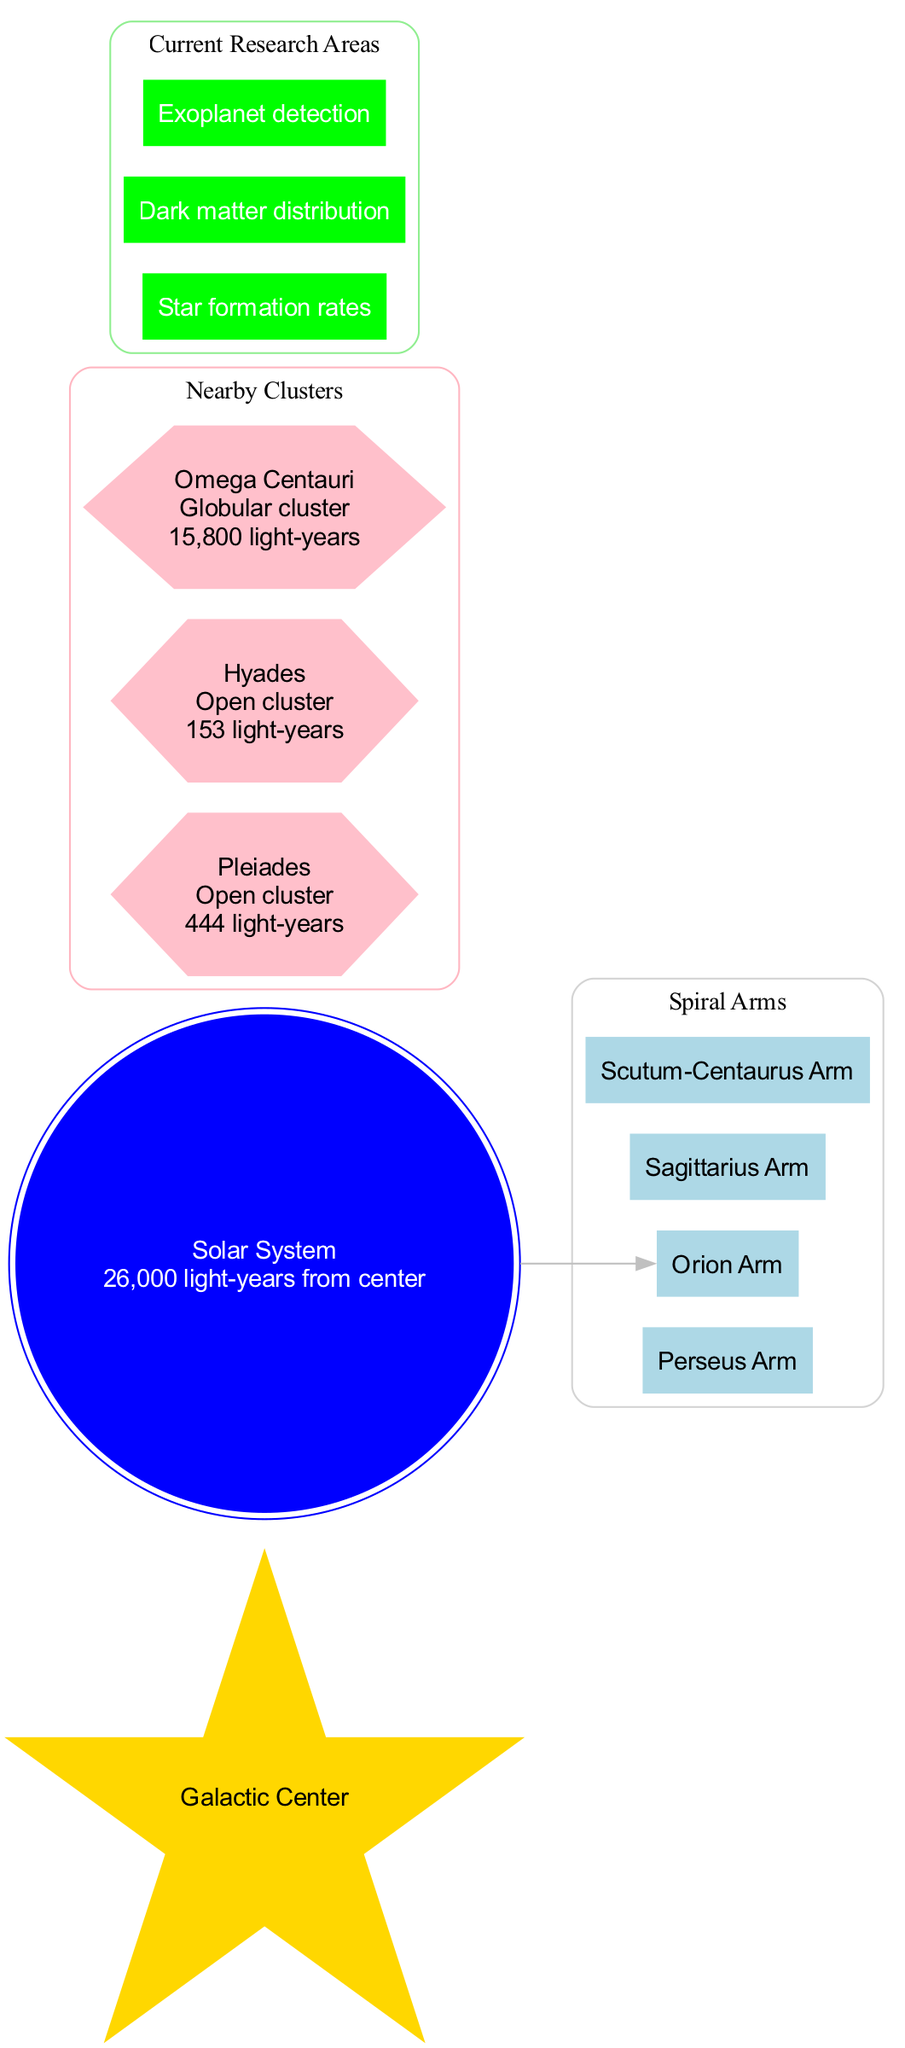What is the distance from the Solar System to the Galactic Center? The diagram indicates that the Solar System is 26,000 light-years away from the Galactic Center, which is explicitly noted next to the Solar System node.
Answer: 26,000 light-years How many spiral arms are shown in the diagram? The diagram lists four distinct spiral arms: Perseus Arm, Orion Arm, Sagittarius Arm, and Scutum-Centaurus Arm, which can be counted directly from the diagram's subgraph for spiral arms.
Answer: 4 Which arm is the Solar System located in? The diagram shows that the Solar System is located in the Orion Arm, indicated clearly by the edge connecting the Solar System node to the arm node.
Answer: Orion Arm What type of cluster is Pleiades? The Pleiades cluster is described as an Open cluster in the diagram, which is specified in its node details.
Answer: Open cluster What is the distance to Omega Centauri? According to the diagram, Omega Centauri is located 15,800 light-years away, as shown in the cluster's information on the diagram.
Answer: 15,800 light-years How many areas of current research are listed in the diagram? The diagram highlights three areas of current research: Star formation rates, Dark matter distribution, and Exoplanet detection, which can be counted directly from the information presented in the subgraph for research areas.
Answer: 3 Which nearby cluster is the farthest from the Solar System? Among the clusters listed in the diagram, Omega Centauri at 15,800 light-years is the farthest, compared to Pleiades and Hyades, whose distances are smaller.
Answer: Omega Centauri What color represents the Galactic Center in the diagram? The Galactic Center is represented by a gold color, distinctly shown in the node for the Galactic Center in the diagram.
Answer: Gold Which research area involves the study of extra-solar planets? The research area that pertains to the study of extra-solar planets, or exoplanets, is called Exoplanet detection, which can be found in the current research areas of the diagram.
Answer: Exoplanet detection 